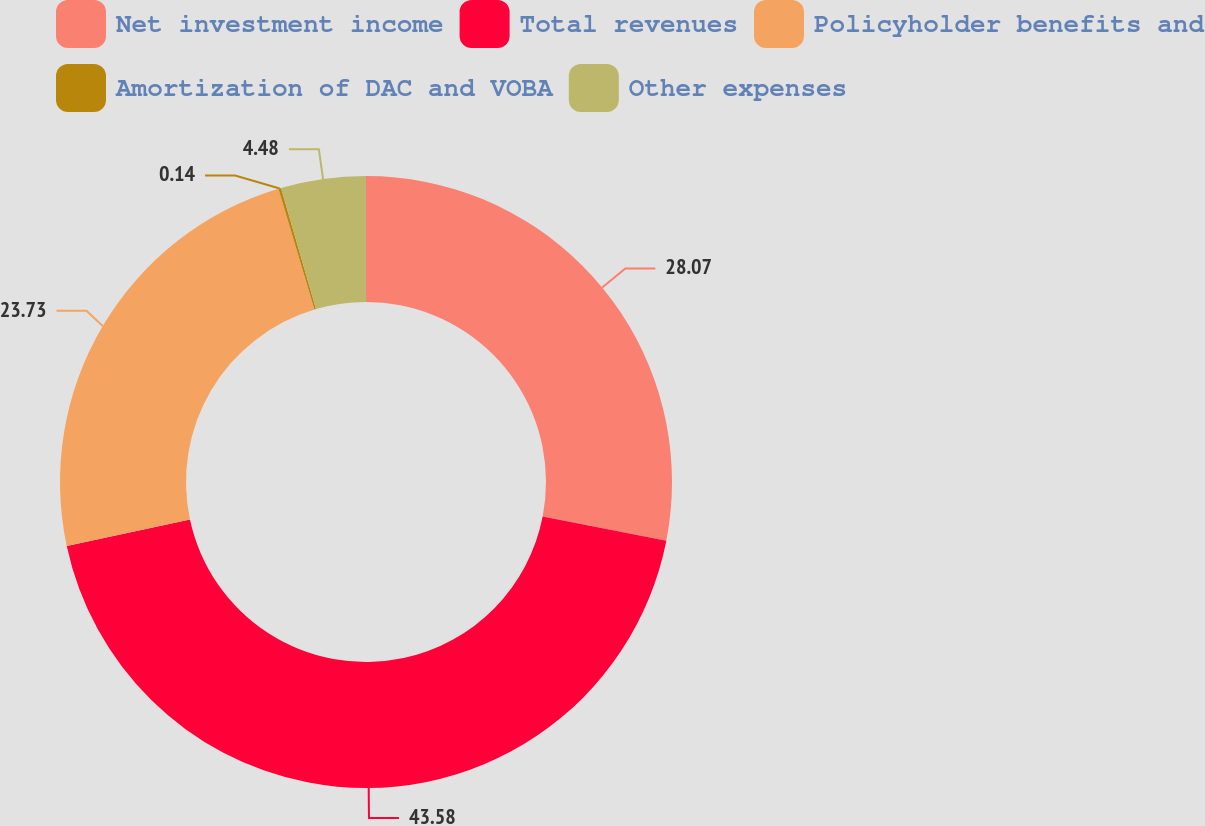Convert chart. <chart><loc_0><loc_0><loc_500><loc_500><pie_chart><fcel>Net investment income<fcel>Total revenues<fcel>Policyholder benefits and<fcel>Amortization of DAC and VOBA<fcel>Other expenses<nl><fcel>28.07%<fcel>43.58%<fcel>23.73%<fcel>0.14%<fcel>4.48%<nl></chart> 